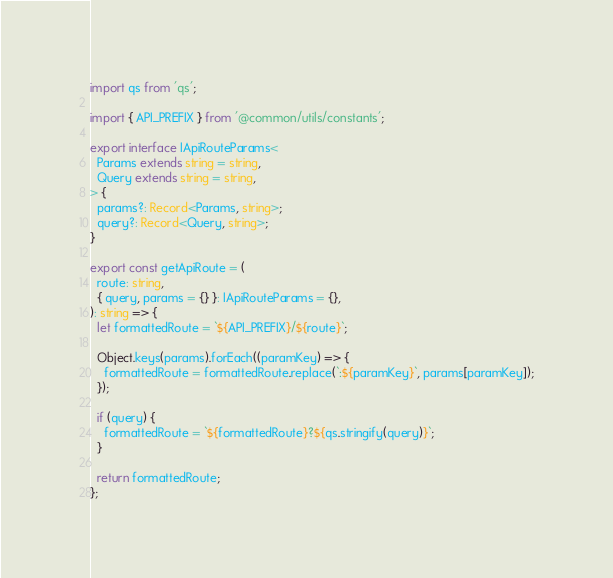Convert code to text. <code><loc_0><loc_0><loc_500><loc_500><_TypeScript_>import qs from 'qs';

import { API_PREFIX } from '@common/utils/constants';

export interface IApiRouteParams<
  Params extends string = string,
  Query extends string = string,
> {
  params?: Record<Params, string>;
  query?: Record<Query, string>;
}

export const getApiRoute = (
  route: string,
  { query, params = {} }: IApiRouteParams = {},
): string => {
  let formattedRoute = `${API_PREFIX}/${route}`;

  Object.keys(params).forEach((paramKey) => {
    formattedRoute = formattedRoute.replace(`:${paramKey}`, params[paramKey]);
  });

  if (query) {
    formattedRoute = `${formattedRoute}?${qs.stringify(query)}`;
  }

  return formattedRoute;
};
</code> 